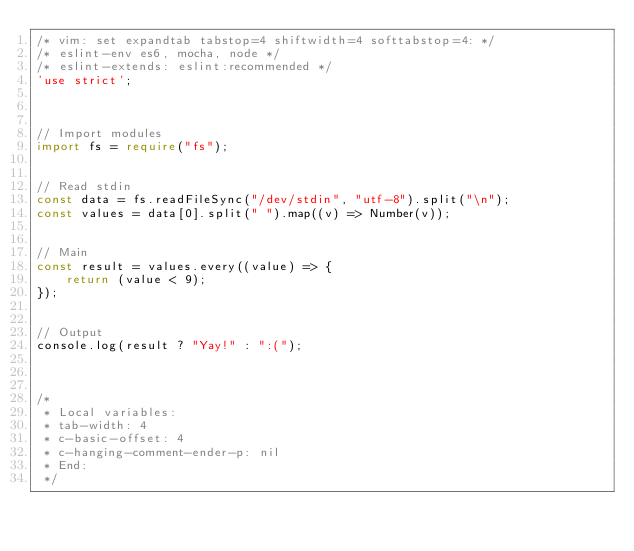<code> <loc_0><loc_0><loc_500><loc_500><_TypeScript_>/* vim: set expandtab tabstop=4 shiftwidth=4 softtabstop=4: */
/* eslint-env es6, mocha, node */
/* eslint-extends: eslint:recommended */
'use strict';



// Import modules
import fs = require("fs");


// Read stdin
const data = fs.readFileSync("/dev/stdin", "utf-8").split("\n");
const values = data[0].split(" ").map((v) => Number(v));


// Main
const result = values.every((value) => {
    return (value < 9);
});


// Output
console.log(result ? "Yay!" : ":(");



/*
 * Local variables:
 * tab-width: 4
 * c-basic-offset: 4
 * c-hanging-comment-ender-p: nil
 * End:
 */</code> 